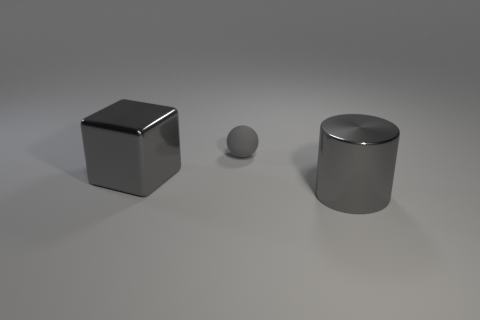What might be the purpose of these objects in a practical setting? These objects, due to their simple geometric shapes, are likely to be used for educational or demonstrative purposes, possibly in a physics or art class to teach about geometry, light, and shadow. 